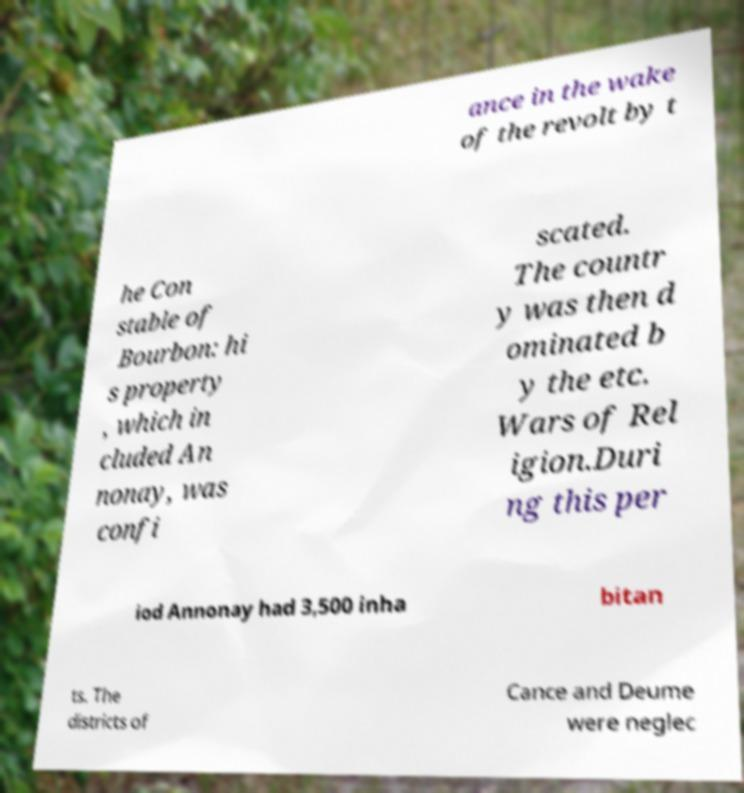I need the written content from this picture converted into text. Can you do that? ance in the wake of the revolt by t he Con stable of Bourbon: hi s property , which in cluded An nonay, was confi scated. The countr y was then d ominated b y the etc. Wars of Rel igion.Duri ng this per iod Annonay had 3,500 inha bitan ts. The districts of Cance and Deume were neglec 